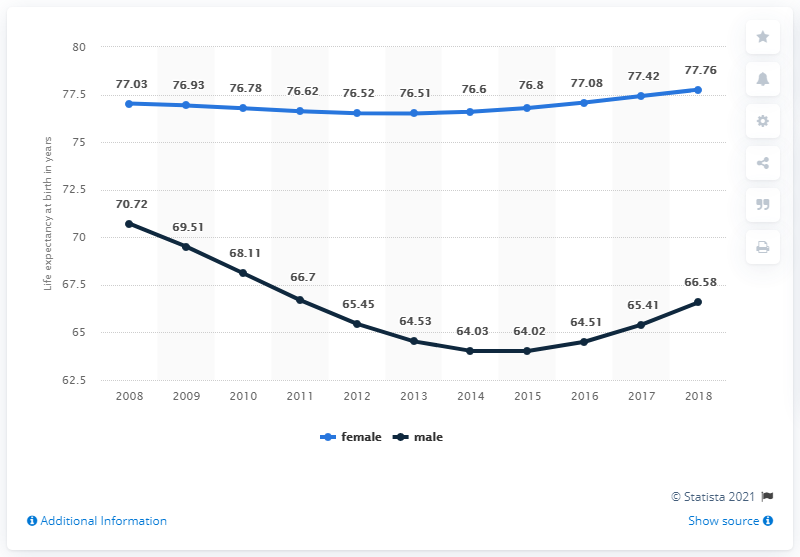Highlight a few significant elements in this photo. Life expectancy for males peaked in 2008. The average life expectancy in 2018 was 72.17 years. 